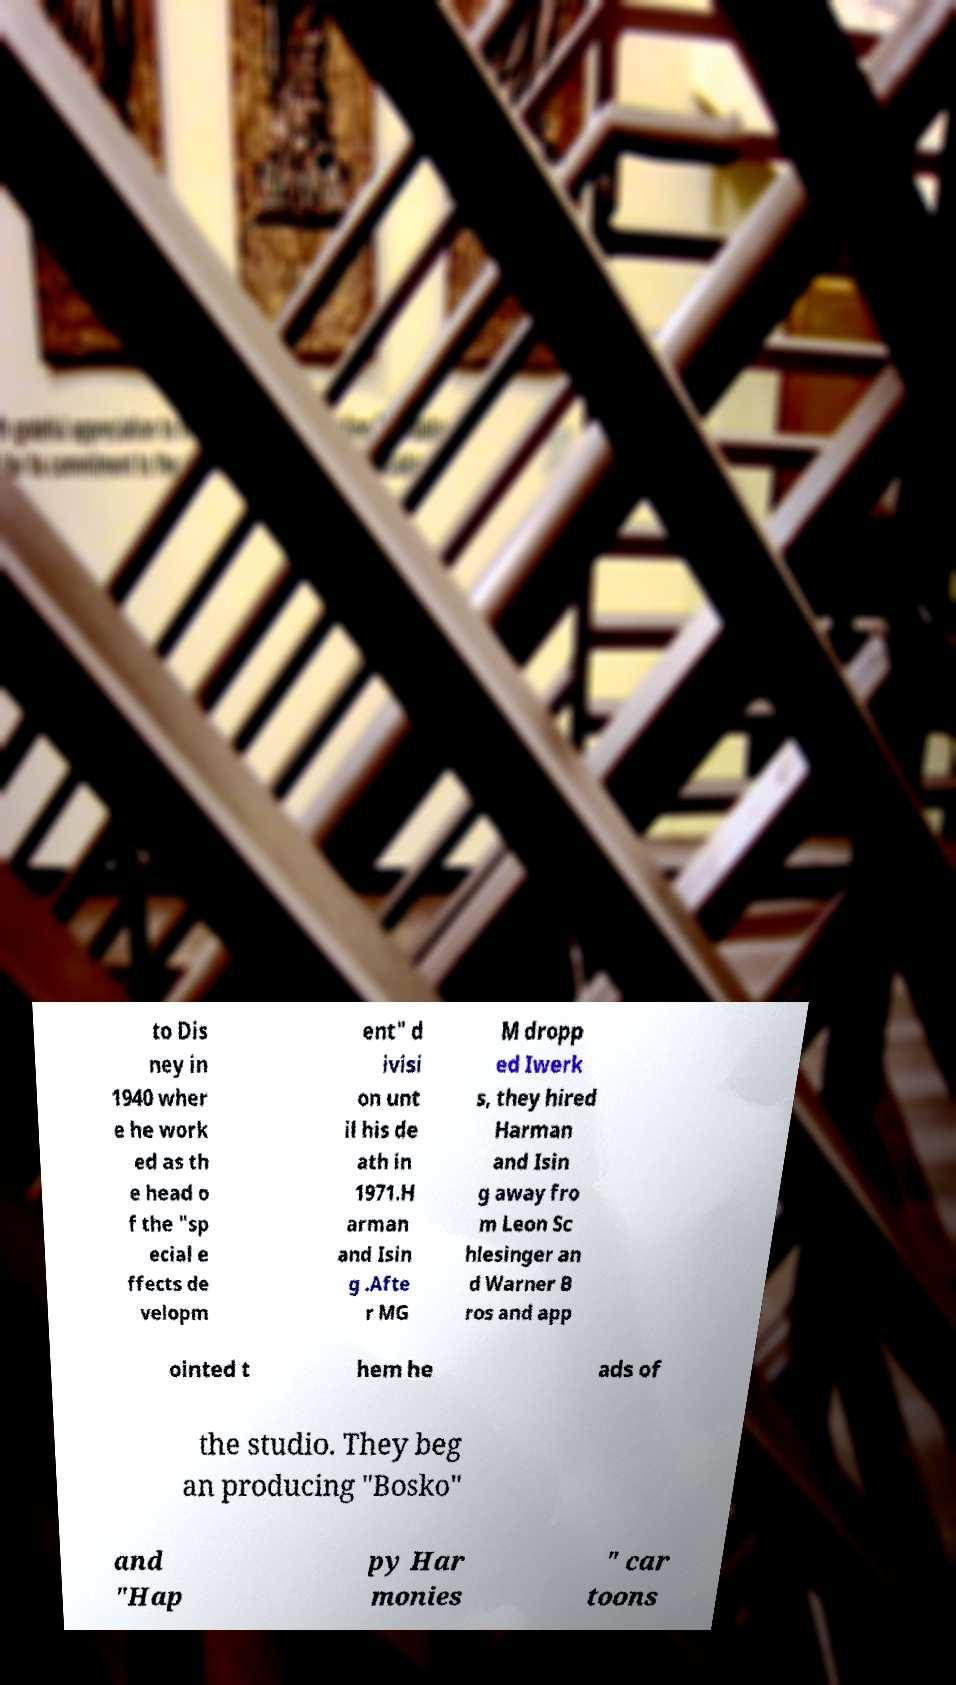For documentation purposes, I need the text within this image transcribed. Could you provide that? to Dis ney in 1940 wher e he work ed as th e head o f the "sp ecial e ffects de velopm ent" d ivisi on unt il his de ath in 1971.H arman and Isin g .Afte r MG M dropp ed Iwerk s, they hired Harman and Isin g away fro m Leon Sc hlesinger an d Warner B ros and app ointed t hem he ads of the studio. They beg an producing "Bosko" and "Hap py Har monies " car toons 